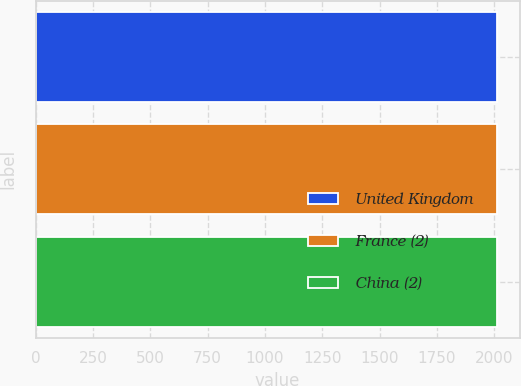Convert chart. <chart><loc_0><loc_0><loc_500><loc_500><bar_chart><fcel>United Kingdom<fcel>France (2)<fcel>China (2)<nl><fcel>2010<fcel>2010.1<fcel>2010.2<nl></chart> 